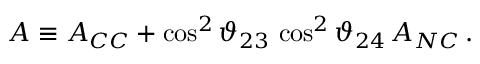<formula> <loc_0><loc_0><loc_500><loc_500>A \equiv A _ { C C } + \cos ^ { 2 } { \vartheta _ { 2 3 } } \, \cos ^ { 2 } { \vartheta _ { 2 4 } } \, A _ { N C } \, .</formula> 